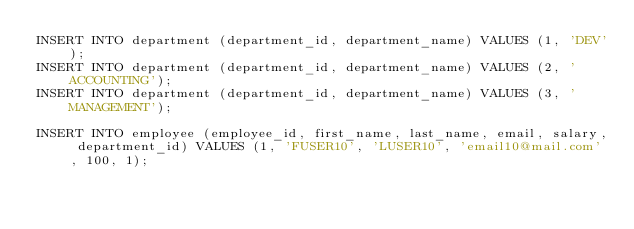Convert code to text. <code><loc_0><loc_0><loc_500><loc_500><_SQL_>INSERT INTO department (department_id, department_name) VALUES (1, 'DEV');
INSERT INTO department (department_id, department_name) VALUES (2, 'ACCOUNTING');
INSERT INTO department (department_id, department_name) VALUES (3, 'MANAGEMENT');

INSERT INTO employee (employee_id, first_name, last_name, email, salary, department_id) VALUES (1, 'FUSER10', 'LUSER10', 'email10@mail.com', 100, 1);</code> 